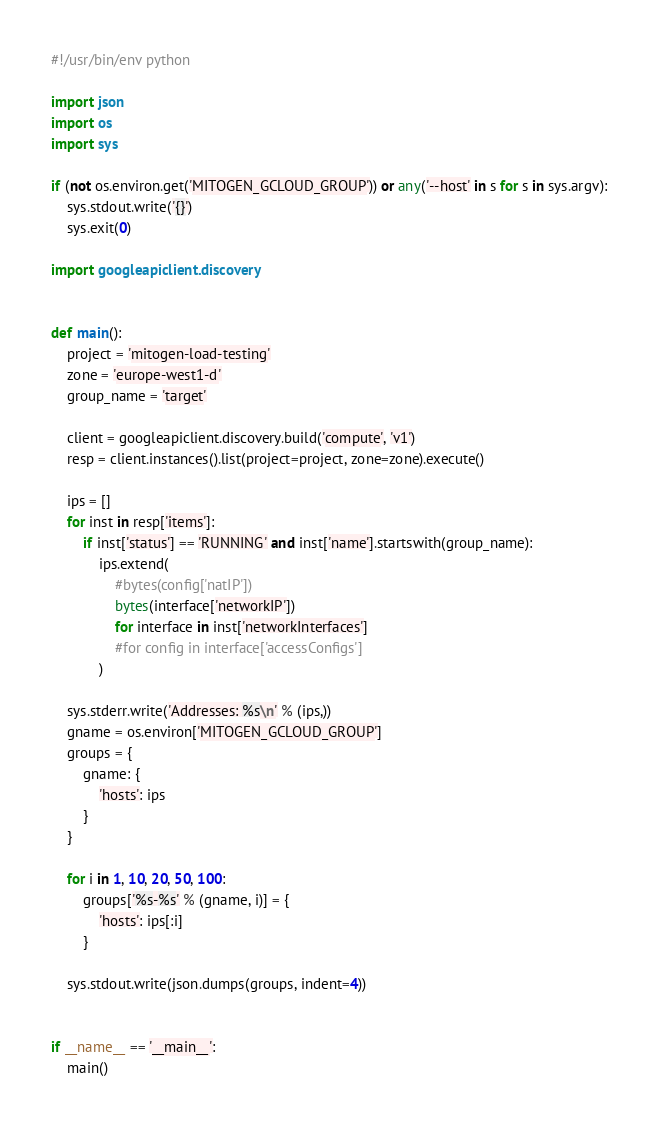<code> <loc_0><loc_0><loc_500><loc_500><_Python_>#!/usr/bin/env python

import json
import os
import sys

if (not os.environ.get('MITOGEN_GCLOUD_GROUP')) or any('--host' in s for s in sys.argv):
    sys.stdout.write('{}')
    sys.exit(0)

import googleapiclient.discovery


def main():
    project = 'mitogen-load-testing'
    zone = 'europe-west1-d'
    group_name = 'target'

    client = googleapiclient.discovery.build('compute', 'v1')
    resp = client.instances().list(project=project, zone=zone).execute()

    ips = []
    for inst in resp['items']:
        if inst['status'] == 'RUNNING' and inst['name'].startswith(group_name):
            ips.extend(
                #bytes(config['natIP'])
                bytes(interface['networkIP'])
                for interface in inst['networkInterfaces']
                #for config in interface['accessConfigs']
            )

    sys.stderr.write('Addresses: %s\n' % (ips,))
    gname = os.environ['MITOGEN_GCLOUD_GROUP']
    groups = {
        gname: {
            'hosts': ips
        }
    }

    for i in 1, 10, 20, 50, 100:
        groups['%s-%s' % (gname, i)] = {
            'hosts': ips[:i]
        }

    sys.stdout.write(json.dumps(groups, indent=4))


if __name__ == '__main__':
    main()
</code> 